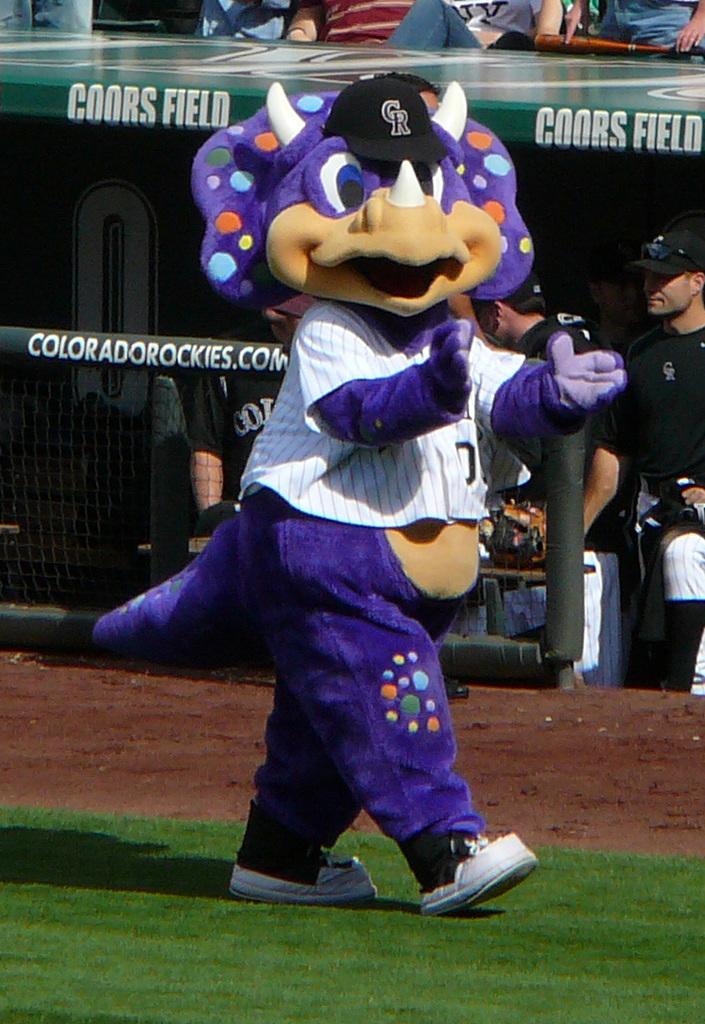What is the name of this stadium?
Ensure brevity in your answer.  Coors field. What initials are on the mascot's hat?
Your response must be concise. Cr. 